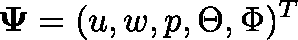Convert formula to latex. <formula><loc_0><loc_0><loc_500><loc_500>\Psi = ( u , w , p , \Theta , \Phi ) ^ { T }</formula> 